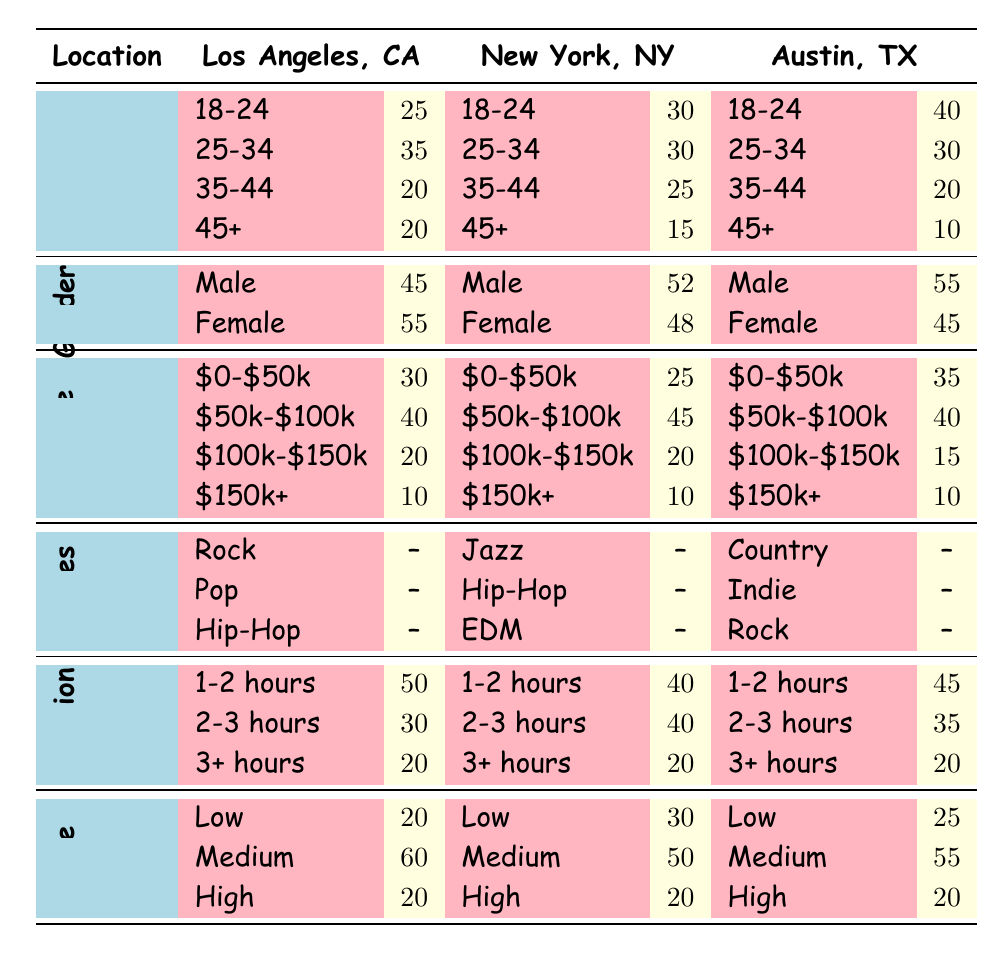What is the largest age group in Los Angeles? The largest age group in Los Angeles is the 25-34 category, with 35% of the audience belonging to this group.
Answer: 25-34 What percentage of the audience in New York prefers a duration of 2-3 hours for events? In New York, 40% of the audience prefers a duration of 2-3 hours for events, as indicated by the relevant row in the table.
Answer: 40 Is the gender ratio in Austin more favorable towards males or females? In Austin, the gender ratio shows 55% male and 45% female, indicating it is more favorable towards males.
Answer: Yes What is the difference in the percentage of the audience aged 45 and older between Los Angeles and New York? In Los Angeles, 20% of the audience is aged 45 and older, while in New York, it is 15%. The difference is 20% - 15% = 5%.
Answer: 5 What is the median income level for the audience in Austin? The income levels in Austin are: $0-$50k (35%), $50k-$100k (40%), $100k-$150k (15%), and $150k+ (10%). To find the median: the second and third values (40% and 15%) give us a median value at $50k-$100k group.
Answer: $50k-$100k What percentage of the audience in New York prefers a ticket price classified as high? In New York, 20% of the audience prefers a ticket price classified as high, based on the table data.
Answer: 20 Which event location has the lowest percentage of audience aged 45 and older? The event location with the lowest percentage of audience aged 45 and older is Austin, with only 10% of the audience in that age group.
Answer: Austin Are there more females than males in the audience in New York? Yes, the audience in New York consists of 52% male and 48% female, meaning there are more males than females.
Answer: No What is the most preferred genre of the audience in Austin? The most preferred genre in Austin is Country, as listed in the favorite genres section of the table.
Answer: Country 